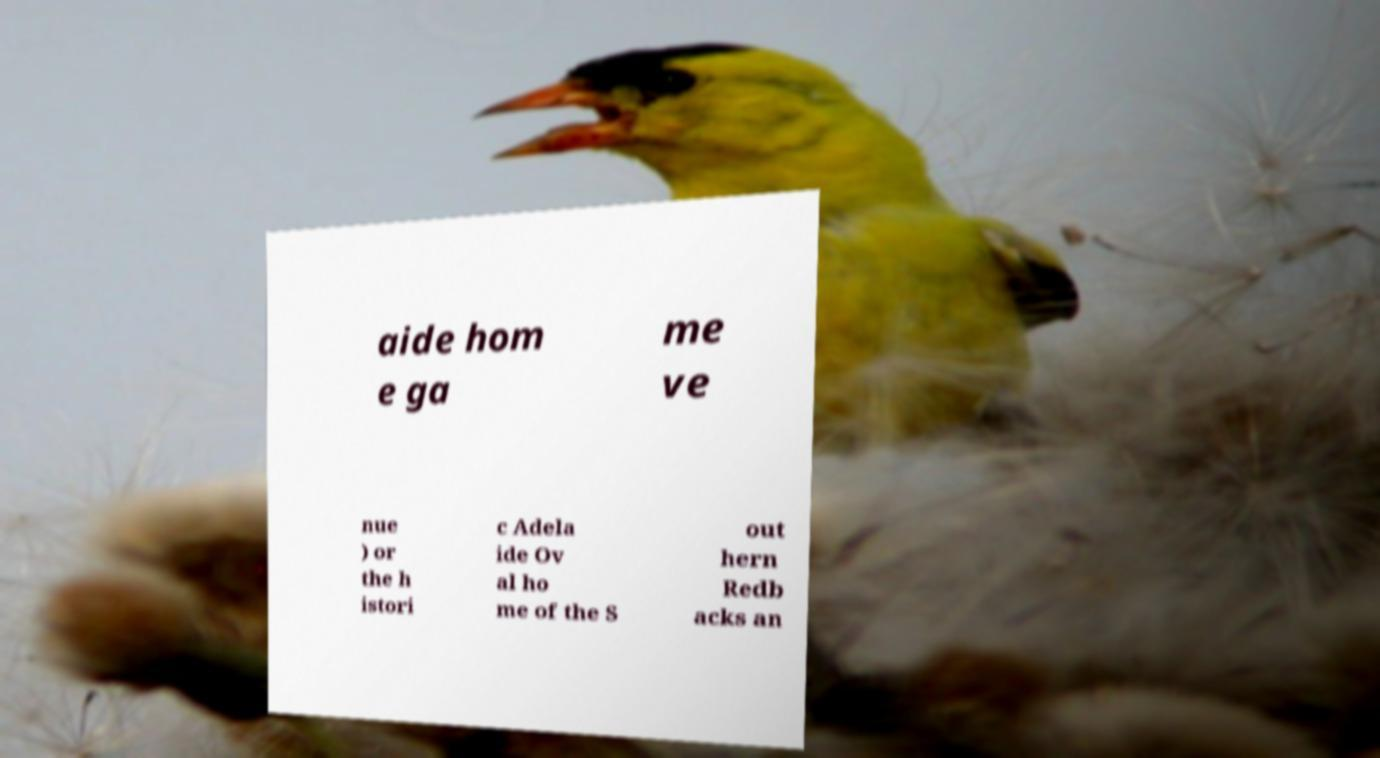For documentation purposes, I need the text within this image transcribed. Could you provide that? aide hom e ga me ve nue ) or the h istori c Adela ide Ov al ho me of the S out hern Redb acks an 